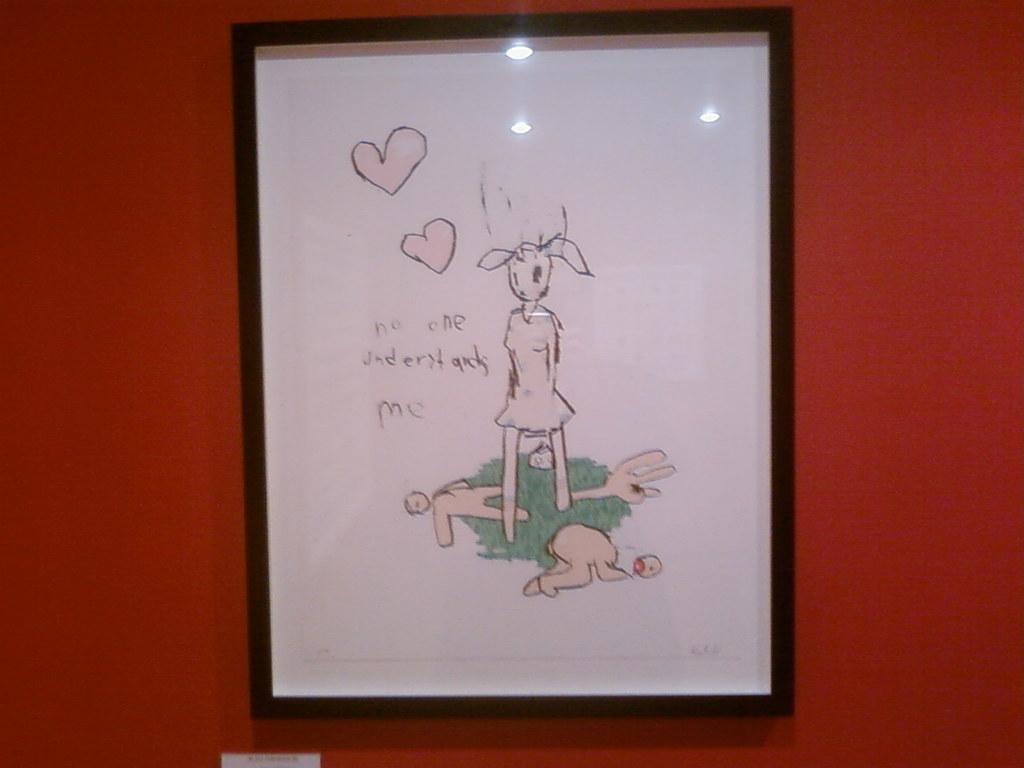<image>
Render a clear and concise summary of the photo. a drawing of what looks like a rabbit standing in a field of people with the words no one understands me written to the left 